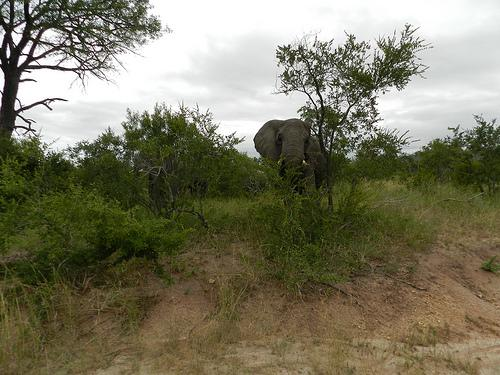Question: what animal is seen in the picture?
Choices:
A. An elephant.
B. Tiger.
C. Panda.
D. Snake.
Answer with the letter. Answer: A Question: when will the elephant walk away?
Choices:
A. When the other elephant comes to get it.
B. When the sun comes up.
C. When the sun goes down.
D. When it is finished eating the grass.
Answer with the letter. Answer: D Question: what color is the elephant?
Choices:
A. Gray.
B. Black.
C. Brown.
D. White.
Answer with the letter. Answer: A Question: who will come to look at the elephant?
Choices:
A. A little boy.
B. A man or woman.
C. A little girl.
D. No one.
Answer with the letter. Answer: B Question: where is this picture taken?
Choices:
A. In a building.
B. At the beach.
C. In an open field.
D. In the mountains.
Answer with the letter. Answer: C Question: how many elephants are there?
Choices:
A. Two.
B. Three.
C. One.
D. Four.
Answer with the letter. Answer: C 